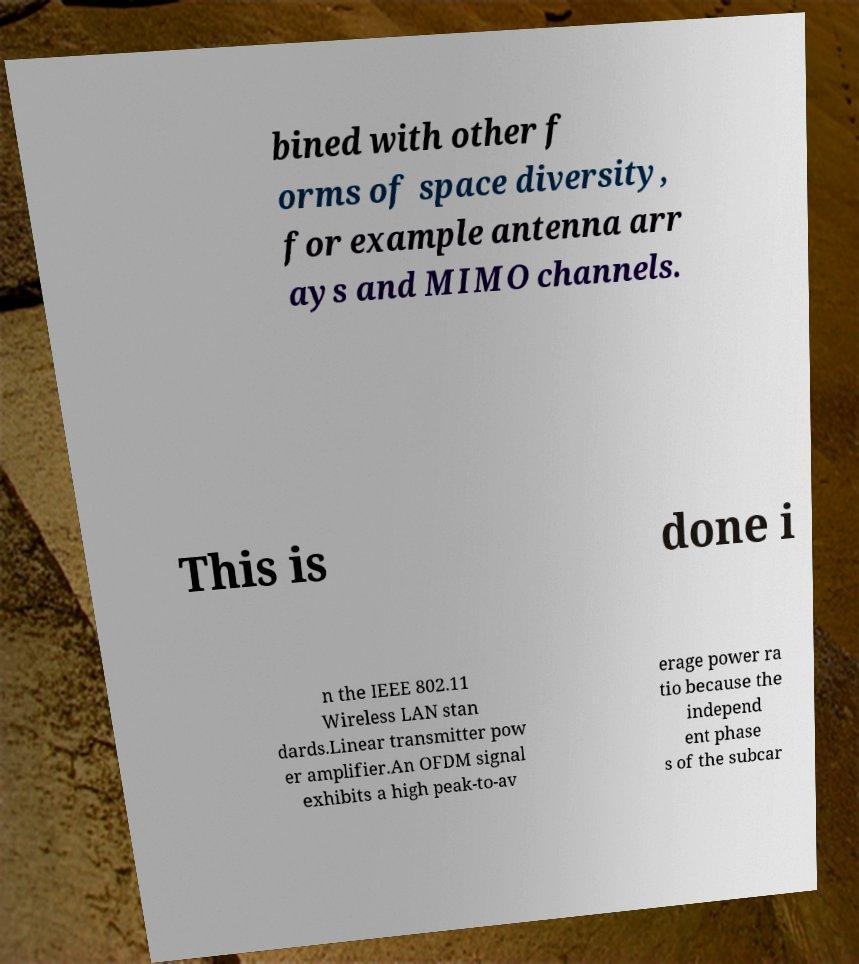There's text embedded in this image that I need extracted. Can you transcribe it verbatim? bined with other f orms of space diversity, for example antenna arr ays and MIMO channels. This is done i n the IEEE 802.11 Wireless LAN stan dards.Linear transmitter pow er amplifier.An OFDM signal exhibits a high peak-to-av erage power ra tio because the independ ent phase s of the subcar 